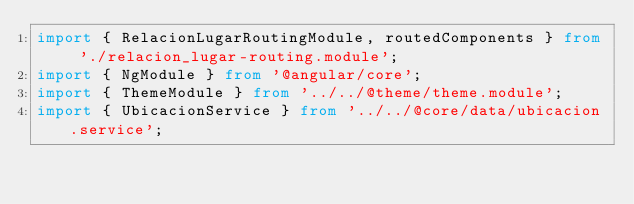<code> <loc_0><loc_0><loc_500><loc_500><_TypeScript_>import { RelacionLugarRoutingModule, routedComponents } from './relacion_lugar-routing.module';
import { NgModule } from '@angular/core';
import { ThemeModule } from '../../@theme/theme.module';
import { UbicacionService } from '../../@core/data/ubicacion.service';</code> 